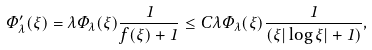<formula> <loc_0><loc_0><loc_500><loc_500>\Phi _ { \lambda } ^ { \prime } ( \xi ) = \lambda \Phi _ { \lambda } ( \xi ) \frac { 1 } { f ( \xi ) + 1 } \leq C \lambda \Phi _ { \lambda } ( \xi ) \frac { 1 } { ( \xi | \log \xi | + 1 ) } ,</formula> 